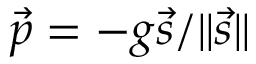<formula> <loc_0><loc_0><loc_500><loc_500>{ \vec { p } } = - g { \vec { s } } / \| { \vec { s } } \| \,</formula> 